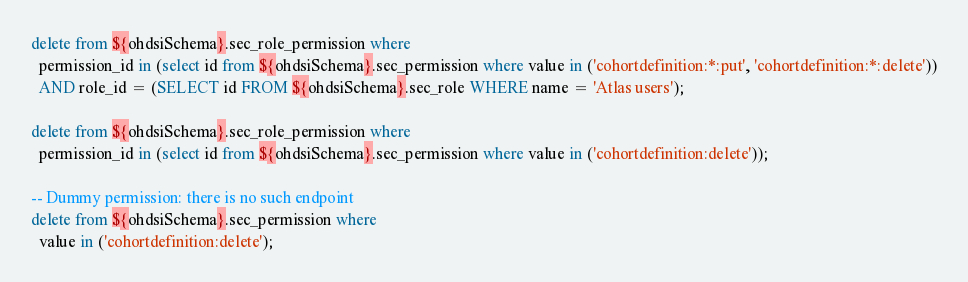Convert code to text. <code><loc_0><loc_0><loc_500><loc_500><_SQL_>delete from ${ohdsiSchema}.sec_role_permission where
  permission_id in (select id from ${ohdsiSchema}.sec_permission where value in ('cohortdefinition:*:put', 'cohortdefinition:*:delete'))
  AND role_id = (SELECT id FROM ${ohdsiSchema}.sec_role WHERE name = 'Atlas users');

delete from ${ohdsiSchema}.sec_role_permission where
  permission_id in (select id from ${ohdsiSchema}.sec_permission where value in ('cohortdefinition:delete'));

-- Dummy permission: there is no such endpoint
delete from ${ohdsiSchema}.sec_permission where
  value in ('cohortdefinition:delete');</code> 